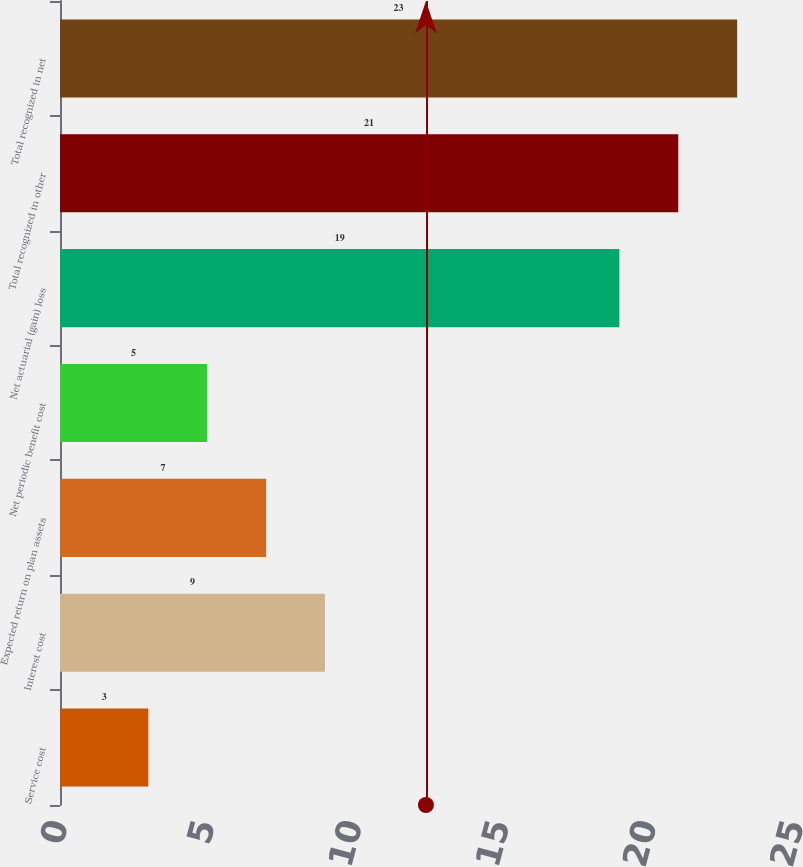<chart> <loc_0><loc_0><loc_500><loc_500><bar_chart><fcel>Service cost<fcel>Interest cost<fcel>Expected return on plan assets<fcel>Net periodic benefit cost<fcel>Net actuarial (gain) loss<fcel>Total recognized in other<fcel>Total recognized in net<nl><fcel>3<fcel>9<fcel>7<fcel>5<fcel>19<fcel>21<fcel>23<nl></chart> 